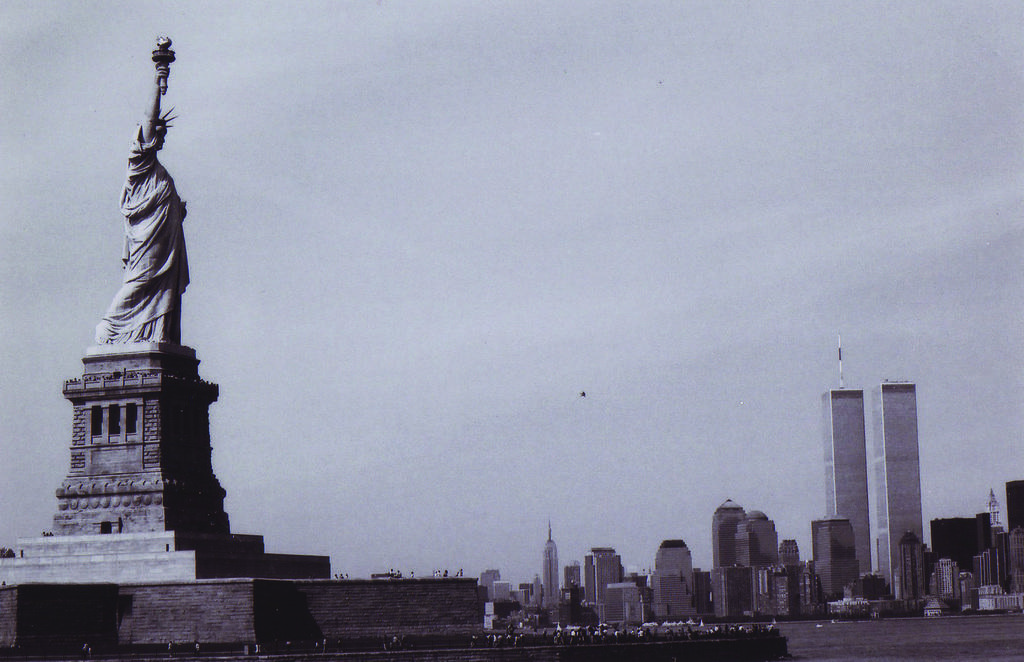Please provide a concise description of this image. It is a black and white image. In this image we can see a statue on the left. In the background we can see many buildings and also the sky. 